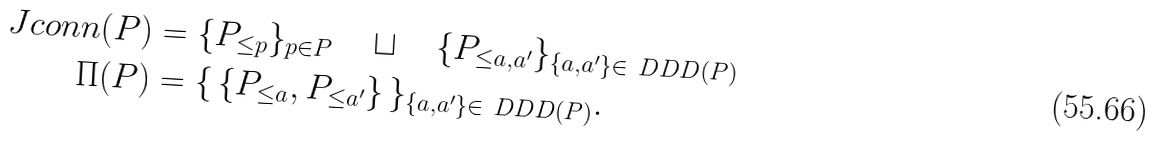<formula> <loc_0><loc_0><loc_500><loc_500>\ J c o n n ( P ) & = \{ P _ { \leq p } \} _ { p \in P } \quad \sqcup \quad \{ P _ { \leq a , a ^ { \prime } } \} _ { \{ a , a ^ { \prime } \} \in \ D D D ( P ) } \\ \Pi ( P ) & = \{ \, \{ P _ { \leq a } , P _ { \leq a ^ { \prime } } \} \, \} _ { \{ a , a ^ { \prime } \} \in \ D D D ( P ) } . \\</formula> 